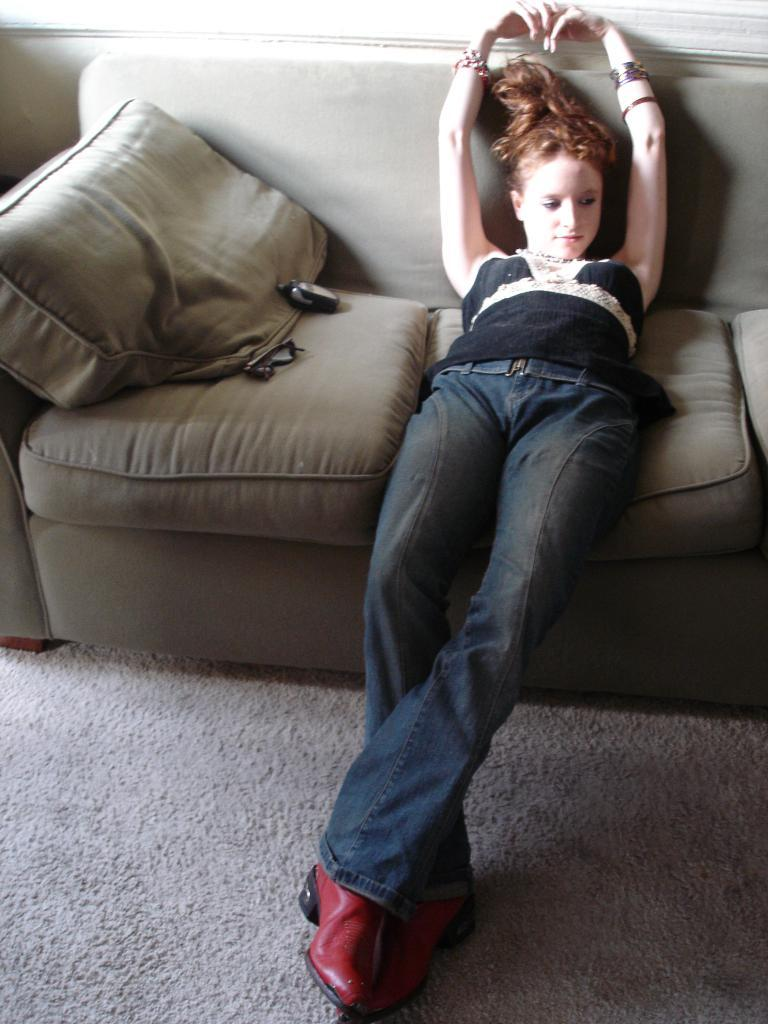What type of furniture is in the image? There is a gray-colored sofa in the image. Who is sitting on the sofa? A girl is sitting on the sofa. What color are the objects on the sofa? The objects on the sofa are black-colored. What verse is the girl teaching from the sofa? There is no indication in the image that the girl is teaching or reciting any verses. 